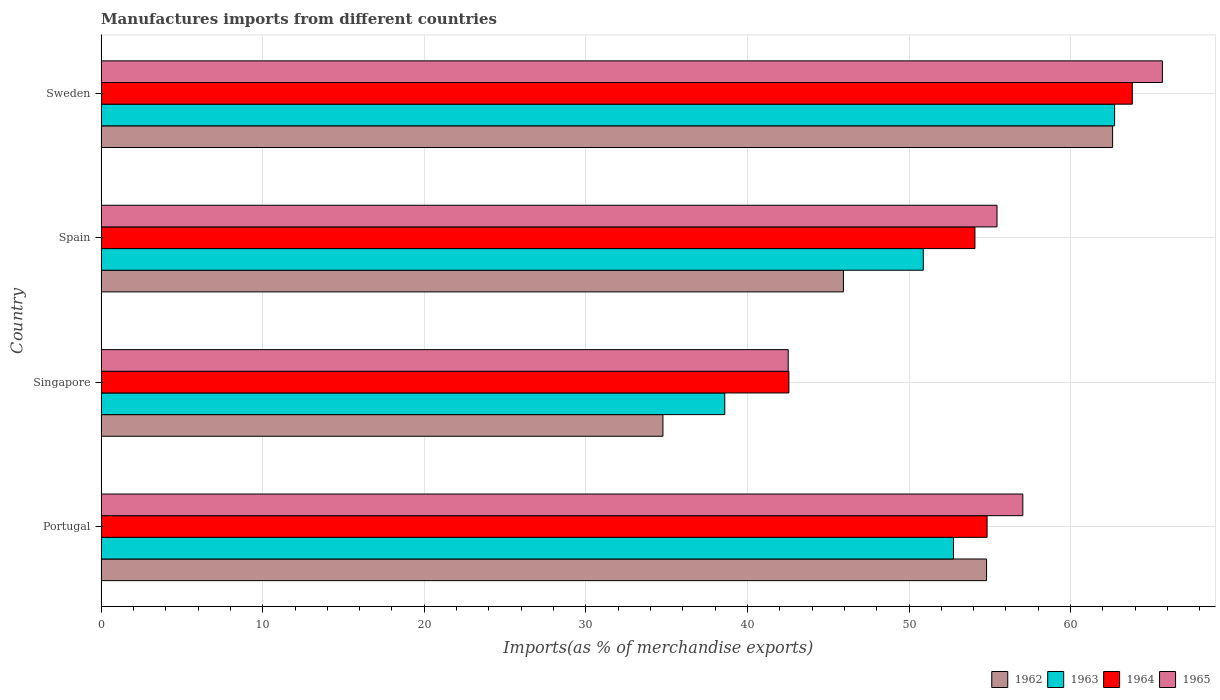How many groups of bars are there?
Your answer should be very brief. 4. Are the number of bars per tick equal to the number of legend labels?
Offer a very short reply. Yes. How many bars are there on the 4th tick from the bottom?
Ensure brevity in your answer.  4. In how many cases, is the number of bars for a given country not equal to the number of legend labels?
Offer a terse response. 0. What is the percentage of imports to different countries in 1962 in Spain?
Offer a terse response. 45.94. Across all countries, what is the maximum percentage of imports to different countries in 1965?
Your answer should be compact. 65.68. Across all countries, what is the minimum percentage of imports to different countries in 1965?
Provide a succinct answer. 42.52. In which country was the percentage of imports to different countries in 1965 maximum?
Keep it short and to the point. Sweden. In which country was the percentage of imports to different countries in 1965 minimum?
Make the answer very short. Singapore. What is the total percentage of imports to different countries in 1963 in the graph?
Offer a very short reply. 204.95. What is the difference between the percentage of imports to different countries in 1964 in Portugal and that in Singapore?
Provide a short and direct response. 12.27. What is the difference between the percentage of imports to different countries in 1962 in Portugal and the percentage of imports to different countries in 1964 in Singapore?
Make the answer very short. 12.23. What is the average percentage of imports to different countries in 1962 per country?
Ensure brevity in your answer.  49.53. What is the difference between the percentage of imports to different countries in 1965 and percentage of imports to different countries in 1962 in Sweden?
Your answer should be compact. 3.08. What is the ratio of the percentage of imports to different countries in 1964 in Singapore to that in Spain?
Make the answer very short. 0.79. What is the difference between the highest and the second highest percentage of imports to different countries in 1964?
Offer a very short reply. 8.99. What is the difference between the highest and the lowest percentage of imports to different countries in 1965?
Your answer should be compact. 23.16. In how many countries, is the percentage of imports to different countries in 1965 greater than the average percentage of imports to different countries in 1965 taken over all countries?
Your response must be concise. 3. Is it the case that in every country, the sum of the percentage of imports to different countries in 1962 and percentage of imports to different countries in 1963 is greater than the sum of percentage of imports to different countries in 1965 and percentage of imports to different countries in 1964?
Make the answer very short. No. What does the 4th bar from the top in Spain represents?
Make the answer very short. 1962. What does the 3rd bar from the bottom in Spain represents?
Provide a succinct answer. 1964. How many bars are there?
Offer a very short reply. 16. What is the difference between two consecutive major ticks on the X-axis?
Offer a very short reply. 10. Are the values on the major ticks of X-axis written in scientific E-notation?
Your answer should be very brief. No. Does the graph contain grids?
Your response must be concise. Yes. Where does the legend appear in the graph?
Your response must be concise. Bottom right. How many legend labels are there?
Your answer should be compact. 4. How are the legend labels stacked?
Ensure brevity in your answer.  Horizontal. What is the title of the graph?
Keep it short and to the point. Manufactures imports from different countries. What is the label or title of the X-axis?
Provide a short and direct response. Imports(as % of merchandise exports). What is the label or title of the Y-axis?
Offer a very short reply. Country. What is the Imports(as % of merchandise exports) of 1962 in Portugal?
Offer a terse response. 54.8. What is the Imports(as % of merchandise exports) of 1963 in Portugal?
Offer a very short reply. 52.75. What is the Imports(as % of merchandise exports) of 1964 in Portugal?
Keep it short and to the point. 54.83. What is the Imports(as % of merchandise exports) of 1965 in Portugal?
Give a very brief answer. 57.04. What is the Imports(as % of merchandise exports) of 1962 in Singapore?
Provide a short and direct response. 34.77. What is the Imports(as % of merchandise exports) of 1963 in Singapore?
Your answer should be compact. 38.6. What is the Imports(as % of merchandise exports) in 1964 in Singapore?
Your response must be concise. 42.56. What is the Imports(as % of merchandise exports) of 1965 in Singapore?
Your answer should be very brief. 42.52. What is the Imports(as % of merchandise exports) of 1962 in Spain?
Give a very brief answer. 45.94. What is the Imports(as % of merchandise exports) of 1963 in Spain?
Offer a very short reply. 50.88. What is the Imports(as % of merchandise exports) in 1964 in Spain?
Offer a very short reply. 54.08. What is the Imports(as % of merchandise exports) of 1965 in Spain?
Offer a terse response. 55.44. What is the Imports(as % of merchandise exports) of 1962 in Sweden?
Provide a succinct answer. 62.6. What is the Imports(as % of merchandise exports) in 1963 in Sweden?
Ensure brevity in your answer.  62.72. What is the Imports(as % of merchandise exports) of 1964 in Sweden?
Ensure brevity in your answer.  63.82. What is the Imports(as % of merchandise exports) of 1965 in Sweden?
Offer a terse response. 65.68. Across all countries, what is the maximum Imports(as % of merchandise exports) of 1962?
Ensure brevity in your answer.  62.6. Across all countries, what is the maximum Imports(as % of merchandise exports) of 1963?
Provide a short and direct response. 62.72. Across all countries, what is the maximum Imports(as % of merchandise exports) of 1964?
Give a very brief answer. 63.82. Across all countries, what is the maximum Imports(as % of merchandise exports) of 1965?
Keep it short and to the point. 65.68. Across all countries, what is the minimum Imports(as % of merchandise exports) in 1962?
Make the answer very short. 34.77. Across all countries, what is the minimum Imports(as % of merchandise exports) of 1963?
Ensure brevity in your answer.  38.6. Across all countries, what is the minimum Imports(as % of merchandise exports) in 1964?
Provide a short and direct response. 42.56. Across all countries, what is the minimum Imports(as % of merchandise exports) of 1965?
Your response must be concise. 42.52. What is the total Imports(as % of merchandise exports) in 1962 in the graph?
Keep it short and to the point. 198.11. What is the total Imports(as % of merchandise exports) in 1963 in the graph?
Provide a short and direct response. 204.95. What is the total Imports(as % of merchandise exports) in 1964 in the graph?
Make the answer very short. 215.29. What is the total Imports(as % of merchandise exports) in 1965 in the graph?
Provide a short and direct response. 220.69. What is the difference between the Imports(as % of merchandise exports) in 1962 in Portugal and that in Singapore?
Make the answer very short. 20.03. What is the difference between the Imports(as % of merchandise exports) in 1963 in Portugal and that in Singapore?
Provide a succinct answer. 14.16. What is the difference between the Imports(as % of merchandise exports) of 1964 in Portugal and that in Singapore?
Your answer should be very brief. 12.27. What is the difference between the Imports(as % of merchandise exports) in 1965 in Portugal and that in Singapore?
Give a very brief answer. 14.52. What is the difference between the Imports(as % of merchandise exports) of 1962 in Portugal and that in Spain?
Your response must be concise. 8.86. What is the difference between the Imports(as % of merchandise exports) in 1963 in Portugal and that in Spain?
Your response must be concise. 1.87. What is the difference between the Imports(as % of merchandise exports) of 1964 in Portugal and that in Spain?
Provide a short and direct response. 0.75. What is the difference between the Imports(as % of merchandise exports) of 1965 in Portugal and that in Spain?
Offer a terse response. 1.6. What is the difference between the Imports(as % of merchandise exports) of 1962 in Portugal and that in Sweden?
Offer a terse response. -7.8. What is the difference between the Imports(as % of merchandise exports) in 1963 in Portugal and that in Sweden?
Ensure brevity in your answer.  -9.97. What is the difference between the Imports(as % of merchandise exports) of 1964 in Portugal and that in Sweden?
Provide a succinct answer. -8.99. What is the difference between the Imports(as % of merchandise exports) of 1965 in Portugal and that in Sweden?
Keep it short and to the point. -8.64. What is the difference between the Imports(as % of merchandise exports) of 1962 in Singapore and that in Spain?
Offer a terse response. -11.17. What is the difference between the Imports(as % of merchandise exports) in 1963 in Singapore and that in Spain?
Your answer should be compact. -12.29. What is the difference between the Imports(as % of merchandise exports) in 1964 in Singapore and that in Spain?
Make the answer very short. -11.51. What is the difference between the Imports(as % of merchandise exports) of 1965 in Singapore and that in Spain?
Ensure brevity in your answer.  -12.92. What is the difference between the Imports(as % of merchandise exports) in 1962 in Singapore and that in Sweden?
Your answer should be compact. -27.83. What is the difference between the Imports(as % of merchandise exports) in 1963 in Singapore and that in Sweden?
Provide a short and direct response. -24.13. What is the difference between the Imports(as % of merchandise exports) in 1964 in Singapore and that in Sweden?
Your answer should be compact. -21.25. What is the difference between the Imports(as % of merchandise exports) in 1965 in Singapore and that in Sweden?
Give a very brief answer. -23.16. What is the difference between the Imports(as % of merchandise exports) of 1962 in Spain and that in Sweden?
Provide a succinct answer. -16.66. What is the difference between the Imports(as % of merchandise exports) in 1963 in Spain and that in Sweden?
Ensure brevity in your answer.  -11.84. What is the difference between the Imports(as % of merchandise exports) of 1964 in Spain and that in Sweden?
Offer a very short reply. -9.74. What is the difference between the Imports(as % of merchandise exports) of 1965 in Spain and that in Sweden?
Ensure brevity in your answer.  -10.24. What is the difference between the Imports(as % of merchandise exports) of 1962 in Portugal and the Imports(as % of merchandise exports) of 1963 in Singapore?
Give a very brief answer. 16.2. What is the difference between the Imports(as % of merchandise exports) in 1962 in Portugal and the Imports(as % of merchandise exports) in 1964 in Singapore?
Offer a terse response. 12.23. What is the difference between the Imports(as % of merchandise exports) of 1962 in Portugal and the Imports(as % of merchandise exports) of 1965 in Singapore?
Give a very brief answer. 12.28. What is the difference between the Imports(as % of merchandise exports) of 1963 in Portugal and the Imports(as % of merchandise exports) of 1964 in Singapore?
Give a very brief answer. 10.19. What is the difference between the Imports(as % of merchandise exports) of 1963 in Portugal and the Imports(as % of merchandise exports) of 1965 in Singapore?
Provide a short and direct response. 10.23. What is the difference between the Imports(as % of merchandise exports) in 1964 in Portugal and the Imports(as % of merchandise exports) in 1965 in Singapore?
Offer a terse response. 12.31. What is the difference between the Imports(as % of merchandise exports) in 1962 in Portugal and the Imports(as % of merchandise exports) in 1963 in Spain?
Your answer should be very brief. 3.92. What is the difference between the Imports(as % of merchandise exports) in 1962 in Portugal and the Imports(as % of merchandise exports) in 1964 in Spain?
Offer a terse response. 0.72. What is the difference between the Imports(as % of merchandise exports) of 1962 in Portugal and the Imports(as % of merchandise exports) of 1965 in Spain?
Provide a short and direct response. -0.65. What is the difference between the Imports(as % of merchandise exports) of 1963 in Portugal and the Imports(as % of merchandise exports) of 1964 in Spain?
Offer a very short reply. -1.33. What is the difference between the Imports(as % of merchandise exports) in 1963 in Portugal and the Imports(as % of merchandise exports) in 1965 in Spain?
Your response must be concise. -2.69. What is the difference between the Imports(as % of merchandise exports) in 1964 in Portugal and the Imports(as % of merchandise exports) in 1965 in Spain?
Your answer should be compact. -0.61. What is the difference between the Imports(as % of merchandise exports) of 1962 in Portugal and the Imports(as % of merchandise exports) of 1963 in Sweden?
Keep it short and to the point. -7.92. What is the difference between the Imports(as % of merchandise exports) in 1962 in Portugal and the Imports(as % of merchandise exports) in 1964 in Sweden?
Offer a terse response. -9.02. What is the difference between the Imports(as % of merchandise exports) in 1962 in Portugal and the Imports(as % of merchandise exports) in 1965 in Sweden?
Offer a terse response. -10.88. What is the difference between the Imports(as % of merchandise exports) in 1963 in Portugal and the Imports(as % of merchandise exports) in 1964 in Sweden?
Provide a succinct answer. -11.07. What is the difference between the Imports(as % of merchandise exports) in 1963 in Portugal and the Imports(as % of merchandise exports) in 1965 in Sweden?
Provide a succinct answer. -12.93. What is the difference between the Imports(as % of merchandise exports) of 1964 in Portugal and the Imports(as % of merchandise exports) of 1965 in Sweden?
Give a very brief answer. -10.85. What is the difference between the Imports(as % of merchandise exports) in 1962 in Singapore and the Imports(as % of merchandise exports) in 1963 in Spain?
Your answer should be very brief. -16.11. What is the difference between the Imports(as % of merchandise exports) in 1962 in Singapore and the Imports(as % of merchandise exports) in 1964 in Spain?
Your answer should be very brief. -19.31. What is the difference between the Imports(as % of merchandise exports) of 1962 in Singapore and the Imports(as % of merchandise exports) of 1965 in Spain?
Your response must be concise. -20.68. What is the difference between the Imports(as % of merchandise exports) in 1963 in Singapore and the Imports(as % of merchandise exports) in 1964 in Spain?
Offer a terse response. -15.48. What is the difference between the Imports(as % of merchandise exports) of 1963 in Singapore and the Imports(as % of merchandise exports) of 1965 in Spain?
Offer a very short reply. -16.85. What is the difference between the Imports(as % of merchandise exports) of 1964 in Singapore and the Imports(as % of merchandise exports) of 1965 in Spain?
Offer a very short reply. -12.88. What is the difference between the Imports(as % of merchandise exports) of 1962 in Singapore and the Imports(as % of merchandise exports) of 1963 in Sweden?
Your response must be concise. -27.95. What is the difference between the Imports(as % of merchandise exports) in 1962 in Singapore and the Imports(as % of merchandise exports) in 1964 in Sweden?
Make the answer very short. -29.05. What is the difference between the Imports(as % of merchandise exports) in 1962 in Singapore and the Imports(as % of merchandise exports) in 1965 in Sweden?
Your answer should be very brief. -30.91. What is the difference between the Imports(as % of merchandise exports) in 1963 in Singapore and the Imports(as % of merchandise exports) in 1964 in Sweden?
Make the answer very short. -25.22. What is the difference between the Imports(as % of merchandise exports) in 1963 in Singapore and the Imports(as % of merchandise exports) in 1965 in Sweden?
Make the answer very short. -27.09. What is the difference between the Imports(as % of merchandise exports) of 1964 in Singapore and the Imports(as % of merchandise exports) of 1965 in Sweden?
Keep it short and to the point. -23.12. What is the difference between the Imports(as % of merchandise exports) of 1962 in Spain and the Imports(as % of merchandise exports) of 1963 in Sweden?
Offer a very short reply. -16.78. What is the difference between the Imports(as % of merchandise exports) of 1962 in Spain and the Imports(as % of merchandise exports) of 1964 in Sweden?
Make the answer very short. -17.88. What is the difference between the Imports(as % of merchandise exports) in 1962 in Spain and the Imports(as % of merchandise exports) in 1965 in Sweden?
Your response must be concise. -19.74. What is the difference between the Imports(as % of merchandise exports) of 1963 in Spain and the Imports(as % of merchandise exports) of 1964 in Sweden?
Keep it short and to the point. -12.94. What is the difference between the Imports(as % of merchandise exports) in 1963 in Spain and the Imports(as % of merchandise exports) in 1965 in Sweden?
Your answer should be compact. -14.8. What is the difference between the Imports(as % of merchandise exports) in 1964 in Spain and the Imports(as % of merchandise exports) in 1965 in Sweden?
Make the answer very short. -11.6. What is the average Imports(as % of merchandise exports) in 1962 per country?
Offer a terse response. 49.53. What is the average Imports(as % of merchandise exports) of 1963 per country?
Your response must be concise. 51.24. What is the average Imports(as % of merchandise exports) in 1964 per country?
Offer a very short reply. 53.82. What is the average Imports(as % of merchandise exports) of 1965 per country?
Your answer should be very brief. 55.17. What is the difference between the Imports(as % of merchandise exports) of 1962 and Imports(as % of merchandise exports) of 1963 in Portugal?
Provide a short and direct response. 2.05. What is the difference between the Imports(as % of merchandise exports) of 1962 and Imports(as % of merchandise exports) of 1964 in Portugal?
Offer a very short reply. -0.03. What is the difference between the Imports(as % of merchandise exports) of 1962 and Imports(as % of merchandise exports) of 1965 in Portugal?
Give a very brief answer. -2.24. What is the difference between the Imports(as % of merchandise exports) in 1963 and Imports(as % of merchandise exports) in 1964 in Portugal?
Keep it short and to the point. -2.08. What is the difference between the Imports(as % of merchandise exports) in 1963 and Imports(as % of merchandise exports) in 1965 in Portugal?
Provide a short and direct response. -4.29. What is the difference between the Imports(as % of merchandise exports) in 1964 and Imports(as % of merchandise exports) in 1965 in Portugal?
Give a very brief answer. -2.21. What is the difference between the Imports(as % of merchandise exports) of 1962 and Imports(as % of merchandise exports) of 1963 in Singapore?
Your answer should be very brief. -3.83. What is the difference between the Imports(as % of merchandise exports) of 1962 and Imports(as % of merchandise exports) of 1964 in Singapore?
Your response must be concise. -7.8. What is the difference between the Imports(as % of merchandise exports) in 1962 and Imports(as % of merchandise exports) in 1965 in Singapore?
Offer a terse response. -7.75. What is the difference between the Imports(as % of merchandise exports) in 1963 and Imports(as % of merchandise exports) in 1964 in Singapore?
Provide a short and direct response. -3.97. What is the difference between the Imports(as % of merchandise exports) in 1963 and Imports(as % of merchandise exports) in 1965 in Singapore?
Ensure brevity in your answer.  -3.93. What is the difference between the Imports(as % of merchandise exports) of 1964 and Imports(as % of merchandise exports) of 1965 in Singapore?
Provide a short and direct response. 0.04. What is the difference between the Imports(as % of merchandise exports) of 1962 and Imports(as % of merchandise exports) of 1963 in Spain?
Give a very brief answer. -4.94. What is the difference between the Imports(as % of merchandise exports) in 1962 and Imports(as % of merchandise exports) in 1964 in Spain?
Provide a succinct answer. -8.14. What is the difference between the Imports(as % of merchandise exports) of 1962 and Imports(as % of merchandise exports) of 1965 in Spain?
Your answer should be compact. -9.51. What is the difference between the Imports(as % of merchandise exports) of 1963 and Imports(as % of merchandise exports) of 1964 in Spain?
Ensure brevity in your answer.  -3.2. What is the difference between the Imports(as % of merchandise exports) of 1963 and Imports(as % of merchandise exports) of 1965 in Spain?
Ensure brevity in your answer.  -4.56. What is the difference between the Imports(as % of merchandise exports) in 1964 and Imports(as % of merchandise exports) in 1965 in Spain?
Your answer should be very brief. -1.37. What is the difference between the Imports(as % of merchandise exports) in 1962 and Imports(as % of merchandise exports) in 1963 in Sweden?
Provide a short and direct response. -0.12. What is the difference between the Imports(as % of merchandise exports) in 1962 and Imports(as % of merchandise exports) in 1964 in Sweden?
Your response must be concise. -1.22. What is the difference between the Imports(as % of merchandise exports) of 1962 and Imports(as % of merchandise exports) of 1965 in Sweden?
Offer a very short reply. -3.08. What is the difference between the Imports(as % of merchandise exports) of 1963 and Imports(as % of merchandise exports) of 1964 in Sweden?
Provide a succinct answer. -1.09. What is the difference between the Imports(as % of merchandise exports) of 1963 and Imports(as % of merchandise exports) of 1965 in Sweden?
Your answer should be compact. -2.96. What is the difference between the Imports(as % of merchandise exports) of 1964 and Imports(as % of merchandise exports) of 1965 in Sweden?
Provide a short and direct response. -1.87. What is the ratio of the Imports(as % of merchandise exports) in 1962 in Portugal to that in Singapore?
Give a very brief answer. 1.58. What is the ratio of the Imports(as % of merchandise exports) in 1963 in Portugal to that in Singapore?
Ensure brevity in your answer.  1.37. What is the ratio of the Imports(as % of merchandise exports) in 1964 in Portugal to that in Singapore?
Your answer should be compact. 1.29. What is the ratio of the Imports(as % of merchandise exports) in 1965 in Portugal to that in Singapore?
Your answer should be compact. 1.34. What is the ratio of the Imports(as % of merchandise exports) of 1962 in Portugal to that in Spain?
Make the answer very short. 1.19. What is the ratio of the Imports(as % of merchandise exports) in 1963 in Portugal to that in Spain?
Your response must be concise. 1.04. What is the ratio of the Imports(as % of merchandise exports) in 1964 in Portugal to that in Spain?
Your answer should be compact. 1.01. What is the ratio of the Imports(as % of merchandise exports) of 1965 in Portugal to that in Spain?
Your answer should be very brief. 1.03. What is the ratio of the Imports(as % of merchandise exports) of 1962 in Portugal to that in Sweden?
Make the answer very short. 0.88. What is the ratio of the Imports(as % of merchandise exports) of 1963 in Portugal to that in Sweden?
Keep it short and to the point. 0.84. What is the ratio of the Imports(as % of merchandise exports) in 1964 in Portugal to that in Sweden?
Keep it short and to the point. 0.86. What is the ratio of the Imports(as % of merchandise exports) of 1965 in Portugal to that in Sweden?
Your answer should be compact. 0.87. What is the ratio of the Imports(as % of merchandise exports) in 1962 in Singapore to that in Spain?
Offer a very short reply. 0.76. What is the ratio of the Imports(as % of merchandise exports) in 1963 in Singapore to that in Spain?
Make the answer very short. 0.76. What is the ratio of the Imports(as % of merchandise exports) of 1964 in Singapore to that in Spain?
Your response must be concise. 0.79. What is the ratio of the Imports(as % of merchandise exports) of 1965 in Singapore to that in Spain?
Give a very brief answer. 0.77. What is the ratio of the Imports(as % of merchandise exports) of 1962 in Singapore to that in Sweden?
Your answer should be compact. 0.56. What is the ratio of the Imports(as % of merchandise exports) in 1963 in Singapore to that in Sweden?
Keep it short and to the point. 0.62. What is the ratio of the Imports(as % of merchandise exports) in 1964 in Singapore to that in Sweden?
Your answer should be very brief. 0.67. What is the ratio of the Imports(as % of merchandise exports) of 1965 in Singapore to that in Sweden?
Keep it short and to the point. 0.65. What is the ratio of the Imports(as % of merchandise exports) in 1962 in Spain to that in Sweden?
Offer a very short reply. 0.73. What is the ratio of the Imports(as % of merchandise exports) of 1963 in Spain to that in Sweden?
Your answer should be compact. 0.81. What is the ratio of the Imports(as % of merchandise exports) of 1964 in Spain to that in Sweden?
Ensure brevity in your answer.  0.85. What is the ratio of the Imports(as % of merchandise exports) of 1965 in Spain to that in Sweden?
Your answer should be compact. 0.84. What is the difference between the highest and the second highest Imports(as % of merchandise exports) of 1962?
Keep it short and to the point. 7.8. What is the difference between the highest and the second highest Imports(as % of merchandise exports) in 1963?
Offer a terse response. 9.97. What is the difference between the highest and the second highest Imports(as % of merchandise exports) in 1964?
Your answer should be very brief. 8.99. What is the difference between the highest and the second highest Imports(as % of merchandise exports) of 1965?
Keep it short and to the point. 8.64. What is the difference between the highest and the lowest Imports(as % of merchandise exports) of 1962?
Offer a very short reply. 27.83. What is the difference between the highest and the lowest Imports(as % of merchandise exports) of 1963?
Your answer should be very brief. 24.13. What is the difference between the highest and the lowest Imports(as % of merchandise exports) in 1964?
Your answer should be very brief. 21.25. What is the difference between the highest and the lowest Imports(as % of merchandise exports) of 1965?
Your answer should be compact. 23.16. 